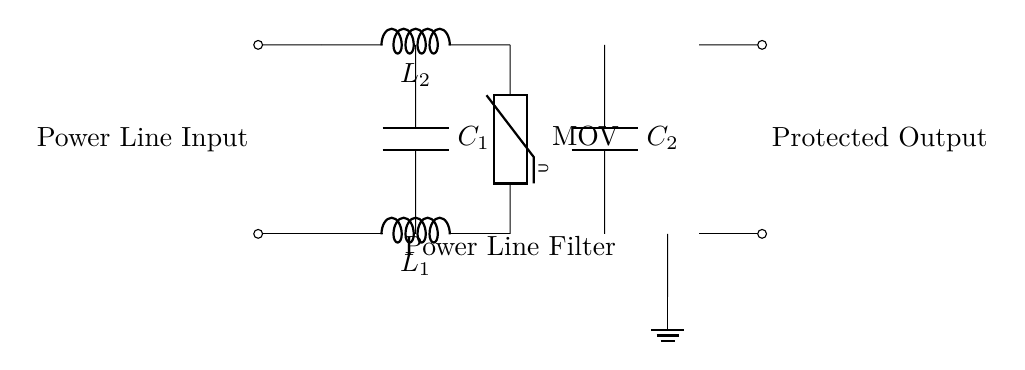What components are used in this filter circuit? The circuit includes inductors, capacitors, and a varistor. Inductors L1 and L2 are used to block high-frequency noise, capacitors C1 and C2 to filter voltage spikes, and the varistor MOV protects against voltage surges.
Answer: inductors, capacitors, varistor What is the purpose of the varistor in this circuit? The varistor, labeled MOV in the diagram, is used to protect the circuit from voltage spikes by clamping excess voltage to a safe level. When the voltage exceeds a certain threshold, it conducts and diverts the surge away from the protected output.
Answer: protect against voltage spikes How many inductors are present in the circuit? There are two inductors, L1 and L2, one for each line. They help in filtering out high-frequency noise from the power line input.
Answer: two What is the arrangement of capacitors in this power line filter? The capacitors C1 and C2 are arranged in parallel between the inductors and the output. This parallel arrangement allows for filtering at both ends of the circuit, ensuring more effective noise reduction.
Answer: parallel How does the design of this circuit protect home electronics? The combination of inductors and capacitors forms a low-pass filter that attenuates high-frequency noise, while the varistor protects against spikes that could damage electronics. Together, they provide a stable and safe power supply to connected devices.
Answer: provides stable power supply What happens if the voltage exceeds a certain limit in this filter circuit? If the voltage exceeds the threshold set by the varistor, it will conduct and divert the excess voltage, thus protecting the rest of the circuit and any connected devices from potential damage.
Answer: excess voltage is diverted 